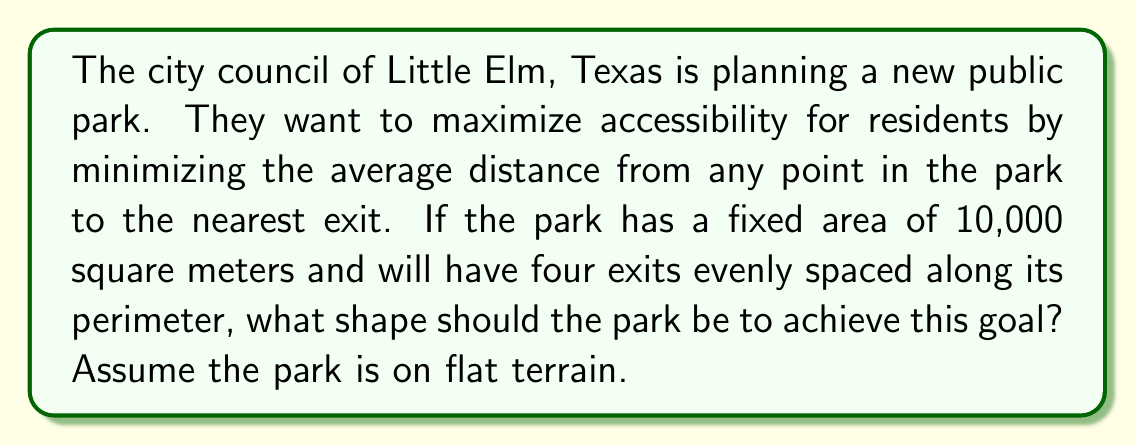Could you help me with this problem? Let's approach this step-by-step:

1) This problem is related to the isoperimetric inequality in differential geometry. The shape that minimizes the average distance to the boundary for a given area is a circle.

2) However, we need to consider the discrete nature of the exits. With four evenly spaced exits, the optimal shape will be a compromise between a circle and a square.

3) The shape that best satisfies these conditions is actually a regular octagon. Here's why:

   a) An octagon approximates a circle better than a square, helping to minimize average distance to the boundary.
   
   b) With four exits, an octagon allows for symmetrical placement of exits at every other vertex, maintaining equal distribution.

4) To determine the dimensions of the octagon, we need to use the area formula for a regular octagon:

   $$A = 2a^2(1+\sqrt{2})$$

   where $A$ is the area and $a$ is the length of a side.

5) Given $A = 10,000$ m², we can solve for $a$:

   $$10,000 = 2a^2(1+\sqrt{2})$$
   $$5,000 = a^2(1+\sqrt{2})$$
   $$a^2 = \frac{5,000}{1+\sqrt{2}} \approx 1,464.47$$
   $$a \approx 38.27\text{ m}$$

6) The inradius (distance from center to middle of a side) of this octagon would be:

   $$r = a\frac{\sqrt{2}+1}{2} \approx 46.14\text{ m}$$

7) This design allows for exits to be placed approximately 92.28 m apart along the perimeter, at alternating vertices of the octagon.

[asy]
import geometry;

size(200);
real a = 38.27;
path p = octagon(a);
draw(p);
dot((a*(1+sqrt(2))/2,0));
dot((0,a*(1+sqrt(2))/2));
dot((-a*(1+sqrt(2))/2,0));
dot((0,-a*(1+sqrt(2))/2));
label("Exit", (a*(1+sqrt(2))/2,0), E);
label("Exit", (0,a*(1+sqrt(2))/2), N);
label("Exit", (-a*(1+sqrt(2))/2,0), W);
label("Exit", (0,-a*(1+sqrt(2))/2), S);
[/asy]
Answer: Regular octagon with side length ≈ 38.27 m 